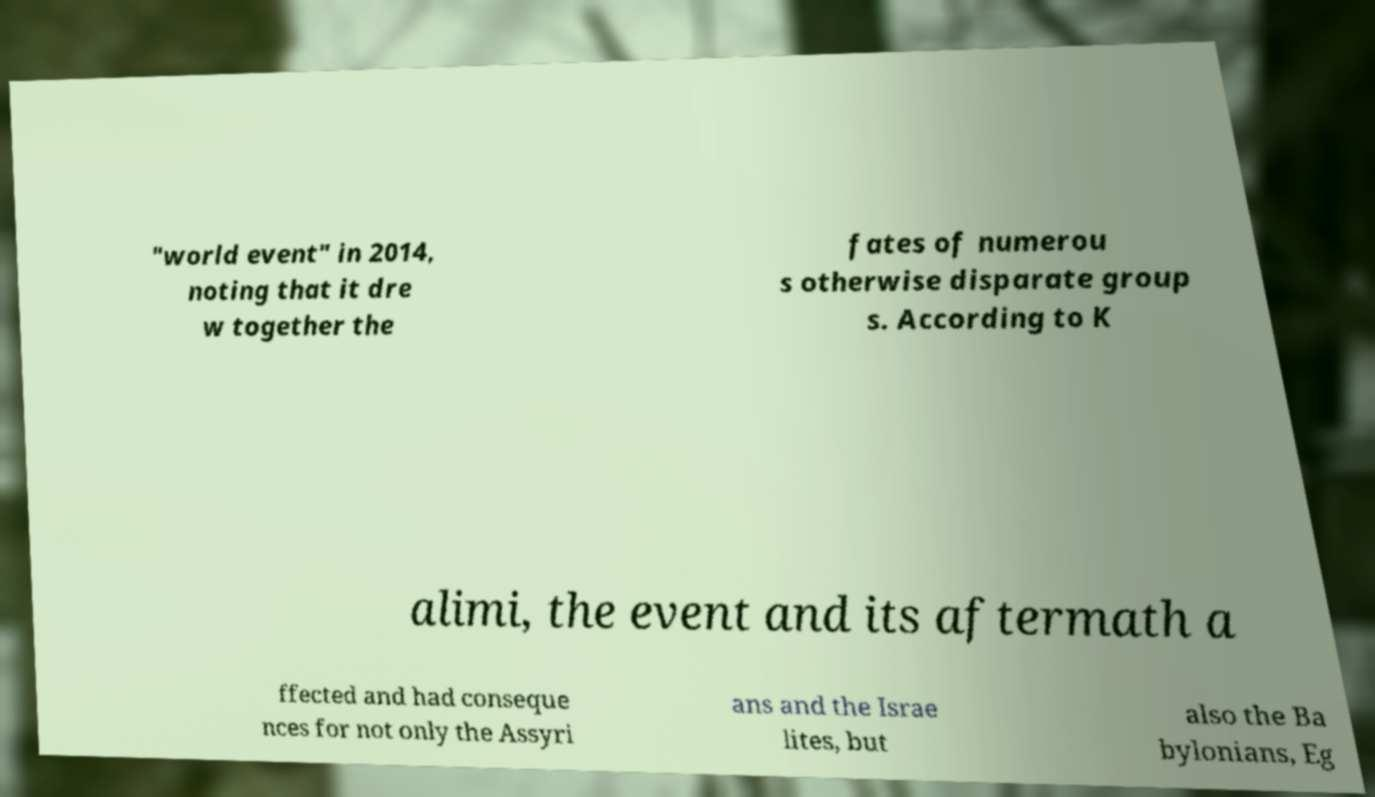I need the written content from this picture converted into text. Can you do that? "world event" in 2014, noting that it dre w together the fates of numerou s otherwise disparate group s. According to K alimi, the event and its aftermath a ffected and had conseque nces for not only the Assyri ans and the Israe lites, but also the Ba bylonians, Eg 